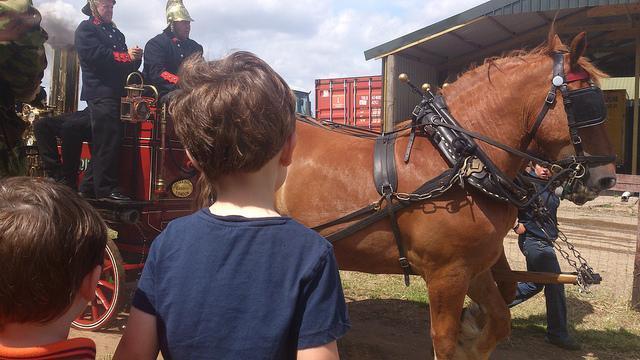How many people are there?
Give a very brief answer. 7. 